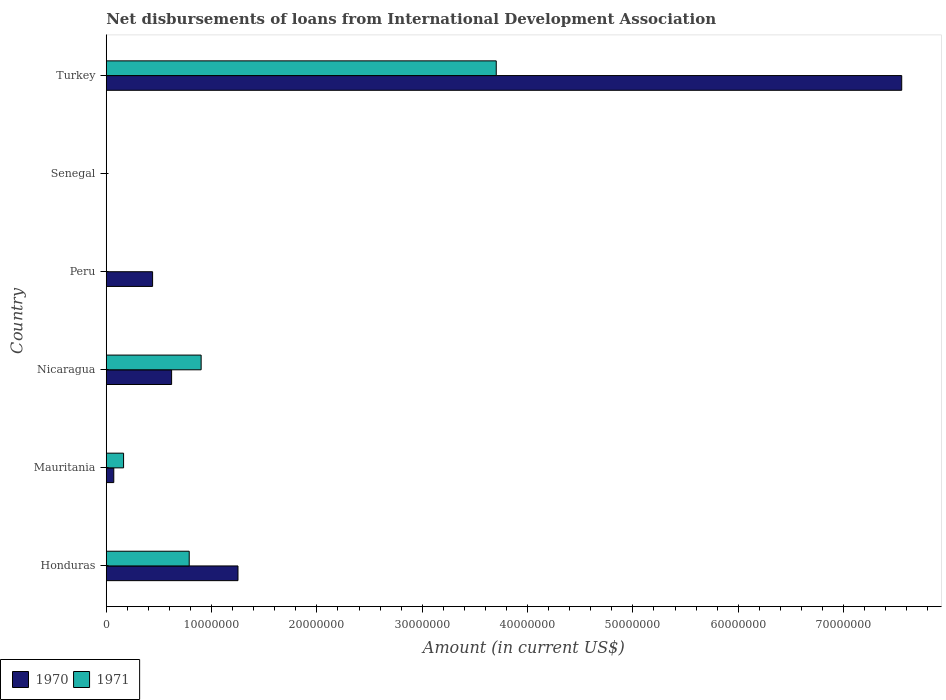Are the number of bars on each tick of the Y-axis equal?
Your response must be concise. No. How many bars are there on the 1st tick from the bottom?
Make the answer very short. 2. What is the label of the 4th group of bars from the top?
Offer a terse response. Nicaragua. What is the amount of loans disbursed in 1970 in Senegal?
Your answer should be very brief. 0. Across all countries, what is the maximum amount of loans disbursed in 1970?
Offer a terse response. 7.55e+07. What is the total amount of loans disbursed in 1971 in the graph?
Provide a short and direct response. 5.56e+07. What is the difference between the amount of loans disbursed in 1971 in Mauritania and that in Turkey?
Offer a terse response. -3.54e+07. What is the difference between the amount of loans disbursed in 1971 in Turkey and the amount of loans disbursed in 1970 in Peru?
Provide a succinct answer. 3.26e+07. What is the average amount of loans disbursed in 1971 per country?
Your answer should be compact. 9.26e+06. What is the difference between the amount of loans disbursed in 1970 and amount of loans disbursed in 1971 in Honduras?
Provide a succinct answer. 4.63e+06. What is the ratio of the amount of loans disbursed in 1971 in Mauritania to that in Turkey?
Your answer should be very brief. 0.04. What is the difference between the highest and the second highest amount of loans disbursed in 1971?
Ensure brevity in your answer.  2.80e+07. What is the difference between the highest and the lowest amount of loans disbursed in 1971?
Keep it short and to the point. 3.70e+07. How many bars are there?
Provide a short and direct response. 9. Are all the bars in the graph horizontal?
Provide a short and direct response. Yes. What is the difference between two consecutive major ticks on the X-axis?
Your answer should be very brief. 1.00e+07. Are the values on the major ticks of X-axis written in scientific E-notation?
Your answer should be very brief. No. Does the graph contain any zero values?
Make the answer very short. Yes. Does the graph contain grids?
Your answer should be compact. No. Where does the legend appear in the graph?
Your answer should be compact. Bottom left. How are the legend labels stacked?
Ensure brevity in your answer.  Horizontal. What is the title of the graph?
Offer a terse response. Net disbursements of loans from International Development Association. What is the Amount (in current US$) of 1970 in Honduras?
Offer a terse response. 1.25e+07. What is the Amount (in current US$) of 1971 in Honduras?
Provide a short and direct response. 7.88e+06. What is the Amount (in current US$) of 1970 in Mauritania?
Your response must be concise. 7.15e+05. What is the Amount (in current US$) in 1971 in Mauritania?
Your answer should be compact. 1.64e+06. What is the Amount (in current US$) in 1970 in Nicaragua?
Provide a succinct answer. 6.21e+06. What is the Amount (in current US$) of 1971 in Nicaragua?
Offer a terse response. 9.01e+06. What is the Amount (in current US$) of 1970 in Peru?
Provide a short and direct response. 4.40e+06. What is the Amount (in current US$) of 1971 in Peru?
Provide a succinct answer. 0. What is the Amount (in current US$) in 1970 in Senegal?
Your response must be concise. 0. What is the Amount (in current US$) in 1971 in Senegal?
Provide a short and direct response. 0. What is the Amount (in current US$) of 1970 in Turkey?
Provide a short and direct response. 7.55e+07. What is the Amount (in current US$) of 1971 in Turkey?
Offer a very short reply. 3.70e+07. Across all countries, what is the maximum Amount (in current US$) of 1970?
Keep it short and to the point. 7.55e+07. Across all countries, what is the maximum Amount (in current US$) in 1971?
Offer a terse response. 3.70e+07. What is the total Amount (in current US$) of 1970 in the graph?
Provide a succinct answer. 9.94e+07. What is the total Amount (in current US$) in 1971 in the graph?
Make the answer very short. 5.56e+07. What is the difference between the Amount (in current US$) of 1970 in Honduras and that in Mauritania?
Provide a succinct answer. 1.18e+07. What is the difference between the Amount (in current US$) of 1971 in Honduras and that in Mauritania?
Keep it short and to the point. 6.23e+06. What is the difference between the Amount (in current US$) in 1970 in Honduras and that in Nicaragua?
Provide a succinct answer. 6.30e+06. What is the difference between the Amount (in current US$) of 1971 in Honduras and that in Nicaragua?
Offer a terse response. -1.13e+06. What is the difference between the Amount (in current US$) in 1970 in Honduras and that in Peru?
Provide a succinct answer. 8.11e+06. What is the difference between the Amount (in current US$) of 1970 in Honduras and that in Turkey?
Your response must be concise. -6.30e+07. What is the difference between the Amount (in current US$) of 1971 in Honduras and that in Turkey?
Your answer should be compact. -2.92e+07. What is the difference between the Amount (in current US$) in 1970 in Mauritania and that in Nicaragua?
Offer a terse response. -5.49e+06. What is the difference between the Amount (in current US$) of 1971 in Mauritania and that in Nicaragua?
Ensure brevity in your answer.  -7.36e+06. What is the difference between the Amount (in current US$) of 1970 in Mauritania and that in Peru?
Offer a very short reply. -3.68e+06. What is the difference between the Amount (in current US$) of 1970 in Mauritania and that in Turkey?
Make the answer very short. -7.48e+07. What is the difference between the Amount (in current US$) of 1971 in Mauritania and that in Turkey?
Offer a very short reply. -3.54e+07. What is the difference between the Amount (in current US$) of 1970 in Nicaragua and that in Peru?
Provide a short and direct response. 1.81e+06. What is the difference between the Amount (in current US$) of 1970 in Nicaragua and that in Turkey?
Make the answer very short. -6.93e+07. What is the difference between the Amount (in current US$) of 1971 in Nicaragua and that in Turkey?
Provide a short and direct response. -2.80e+07. What is the difference between the Amount (in current US$) in 1970 in Peru and that in Turkey?
Offer a very short reply. -7.11e+07. What is the difference between the Amount (in current US$) in 1970 in Honduras and the Amount (in current US$) in 1971 in Mauritania?
Your answer should be very brief. 1.09e+07. What is the difference between the Amount (in current US$) of 1970 in Honduras and the Amount (in current US$) of 1971 in Nicaragua?
Offer a terse response. 3.50e+06. What is the difference between the Amount (in current US$) of 1970 in Honduras and the Amount (in current US$) of 1971 in Turkey?
Provide a succinct answer. -2.45e+07. What is the difference between the Amount (in current US$) of 1970 in Mauritania and the Amount (in current US$) of 1971 in Nicaragua?
Give a very brief answer. -8.30e+06. What is the difference between the Amount (in current US$) of 1970 in Mauritania and the Amount (in current US$) of 1971 in Turkey?
Ensure brevity in your answer.  -3.63e+07. What is the difference between the Amount (in current US$) of 1970 in Nicaragua and the Amount (in current US$) of 1971 in Turkey?
Provide a succinct answer. -3.08e+07. What is the difference between the Amount (in current US$) in 1970 in Peru and the Amount (in current US$) in 1971 in Turkey?
Your answer should be compact. -3.26e+07. What is the average Amount (in current US$) of 1970 per country?
Your answer should be compact. 1.66e+07. What is the average Amount (in current US$) of 1971 per country?
Make the answer very short. 9.26e+06. What is the difference between the Amount (in current US$) in 1970 and Amount (in current US$) in 1971 in Honduras?
Your answer should be very brief. 4.63e+06. What is the difference between the Amount (in current US$) in 1970 and Amount (in current US$) in 1971 in Mauritania?
Your answer should be very brief. -9.30e+05. What is the difference between the Amount (in current US$) of 1970 and Amount (in current US$) of 1971 in Nicaragua?
Your response must be concise. -2.80e+06. What is the difference between the Amount (in current US$) of 1970 and Amount (in current US$) of 1971 in Turkey?
Keep it short and to the point. 3.85e+07. What is the ratio of the Amount (in current US$) in 1970 in Honduras to that in Mauritania?
Your answer should be very brief. 17.49. What is the ratio of the Amount (in current US$) of 1971 in Honduras to that in Mauritania?
Keep it short and to the point. 4.79. What is the ratio of the Amount (in current US$) of 1970 in Honduras to that in Nicaragua?
Your answer should be very brief. 2.02. What is the ratio of the Amount (in current US$) in 1971 in Honduras to that in Nicaragua?
Ensure brevity in your answer.  0.87. What is the ratio of the Amount (in current US$) in 1970 in Honduras to that in Peru?
Provide a succinct answer. 2.84. What is the ratio of the Amount (in current US$) of 1970 in Honduras to that in Turkey?
Give a very brief answer. 0.17. What is the ratio of the Amount (in current US$) of 1971 in Honduras to that in Turkey?
Ensure brevity in your answer.  0.21. What is the ratio of the Amount (in current US$) in 1970 in Mauritania to that in Nicaragua?
Provide a short and direct response. 0.12. What is the ratio of the Amount (in current US$) of 1971 in Mauritania to that in Nicaragua?
Make the answer very short. 0.18. What is the ratio of the Amount (in current US$) of 1970 in Mauritania to that in Peru?
Ensure brevity in your answer.  0.16. What is the ratio of the Amount (in current US$) of 1970 in Mauritania to that in Turkey?
Provide a short and direct response. 0.01. What is the ratio of the Amount (in current US$) of 1971 in Mauritania to that in Turkey?
Offer a terse response. 0.04. What is the ratio of the Amount (in current US$) of 1970 in Nicaragua to that in Peru?
Keep it short and to the point. 1.41. What is the ratio of the Amount (in current US$) of 1970 in Nicaragua to that in Turkey?
Ensure brevity in your answer.  0.08. What is the ratio of the Amount (in current US$) in 1971 in Nicaragua to that in Turkey?
Provide a succinct answer. 0.24. What is the ratio of the Amount (in current US$) in 1970 in Peru to that in Turkey?
Your response must be concise. 0.06. What is the difference between the highest and the second highest Amount (in current US$) of 1970?
Keep it short and to the point. 6.30e+07. What is the difference between the highest and the second highest Amount (in current US$) of 1971?
Provide a short and direct response. 2.80e+07. What is the difference between the highest and the lowest Amount (in current US$) of 1970?
Your response must be concise. 7.55e+07. What is the difference between the highest and the lowest Amount (in current US$) in 1971?
Provide a short and direct response. 3.70e+07. 